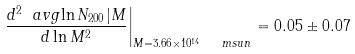Convert formula to latex. <formula><loc_0><loc_0><loc_500><loc_500>\left . \frac { d ^ { 2 } \ a v g { \ln N _ { 2 0 0 } | M } } { d \ln M ^ { 2 } } \right | _ { M = 3 . 6 6 \times 1 0 ^ { 1 4 } \ \ m s u n } = 0 . 0 5 \pm 0 . 0 7</formula> 